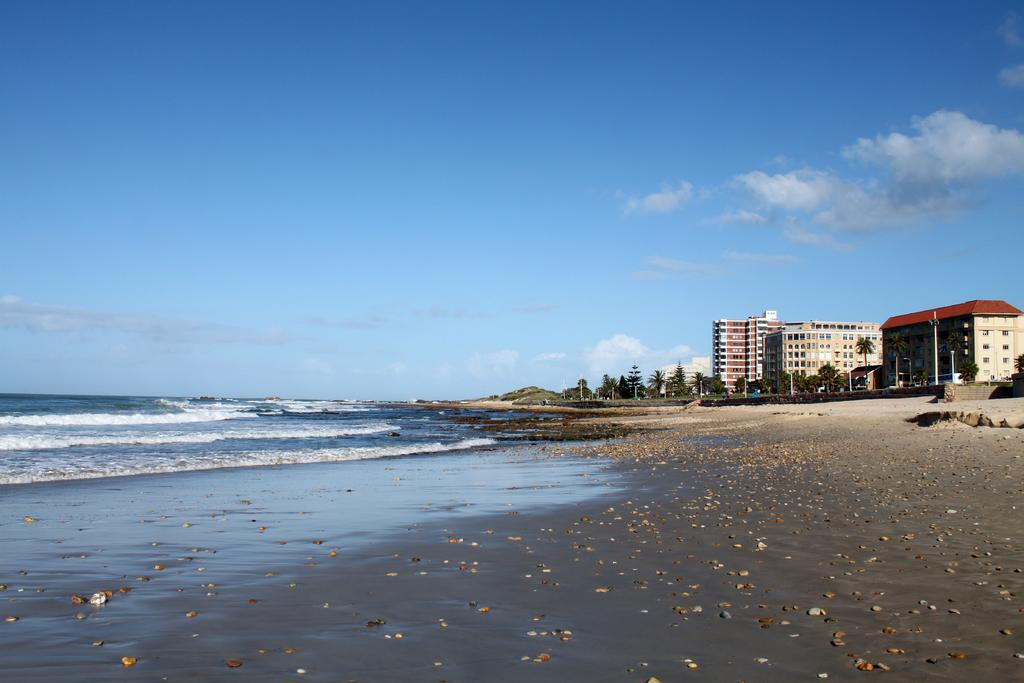What is one of the main elements in the image? There is water in the image. What other natural element is present in the image? There is sand in the image. What can be found on the sand? There are stones on the sand. What can be seen in the distance in the image? There are buildings and trees in the background of the image. What is the condition of the sky in the image? The sky is clear and visible in the image. How long does it take for the mountain to appear in the image? There is no mountain present in the image, so it cannot appear. 